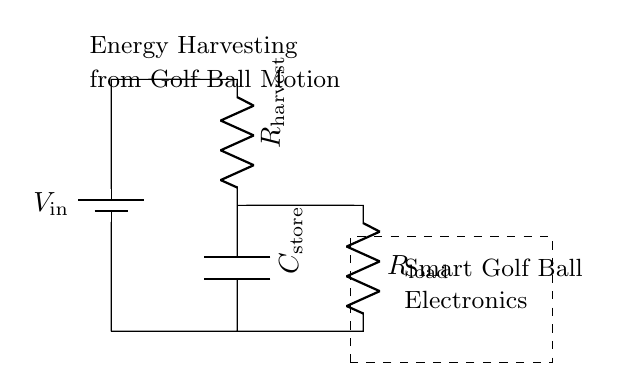What is the input voltage source labeled? The input voltage source is labeled as V_in. In the circuit diagram, the text next to the battery symbol indicates its designation, which is a standard way to represent voltage sources in circuit schematics.
Answer: V_in What type of component is C_store? C_store is a capacitor. The symbol for the capacitor in the diagram indicates its function, and the label alongside confirms it as a storage component.
Answer: Capacitor What does R_harvest do in this circuit? R_harvest is the harvesting resistor. It is part of the energy harvesting system from golf ball motion, providing resistance to the flow of current generated by the input source.
Answer: Harvesting resistor How many resistors are present in the circuit? There are two resistors present in the circuit: R_harvest and R_load. Each resistor's label in the circuit helps in identifying their roles; R_harvest is for harvesting energy, while R_load is for load management.
Answer: Two What is the role of the C_store component? C_store functions as an energy storage component. It charges when energy is harvested and discharges to power the load when needed, which is essential for maintaining power supply in the smart golf ball system.
Answer: Energy storage What is the relationship between R_harvest and R_load? R_harvest functions in series with R_load. The configuration indicates that the total resistance faced by the input source affects the overall energy harvesting efficiency and power distribution in the circuit.
Answer: Series What energy source does this circuit utilize? The circuit utilizes energy from golf ball motion. The label indicates that energy is harvested from the movement of the golf ball, which is then converted and stored for later use in powering its electronics.
Answer: Golf ball motion 